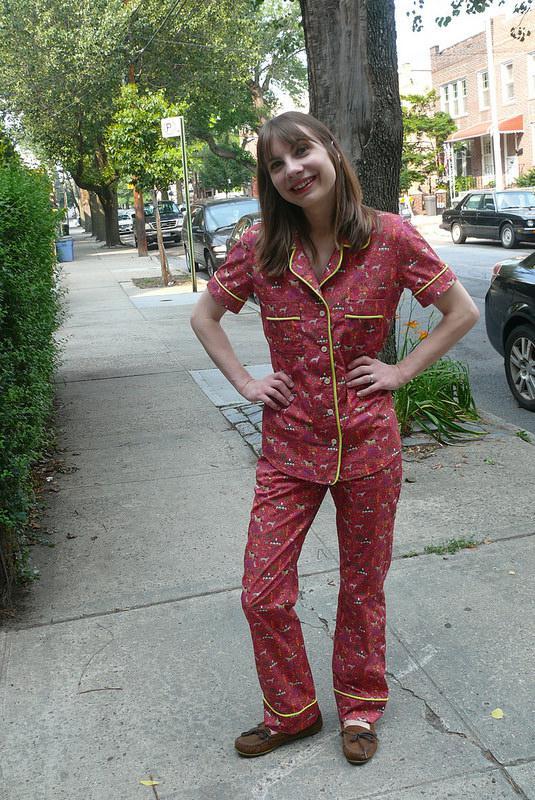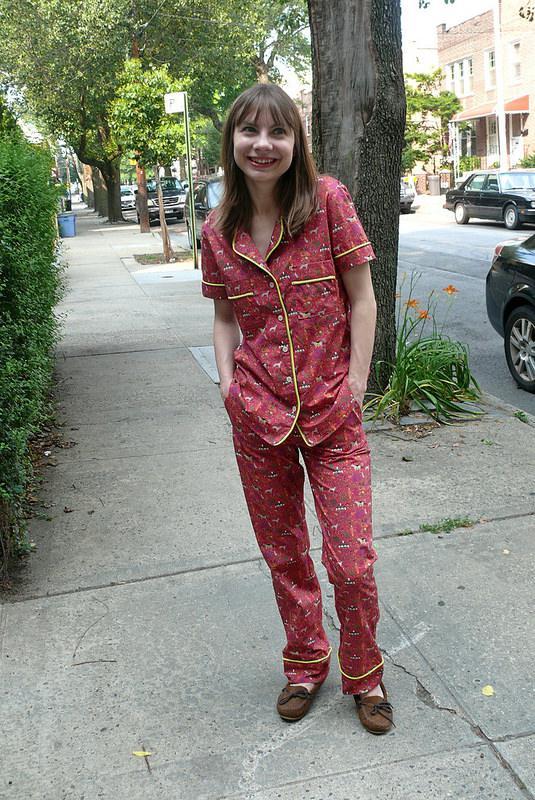The first image is the image on the left, the second image is the image on the right. For the images displayed, is the sentence "The lefthand image shows a pair of pajama-clad models in side-by-side views." factually correct? Answer yes or no. No. The first image is the image on the left, the second image is the image on the right. For the images displayed, is the sentence "The right image contains a human wearing a red pajama top while standing outside on a sidewalk." factually correct? Answer yes or no. Yes. 